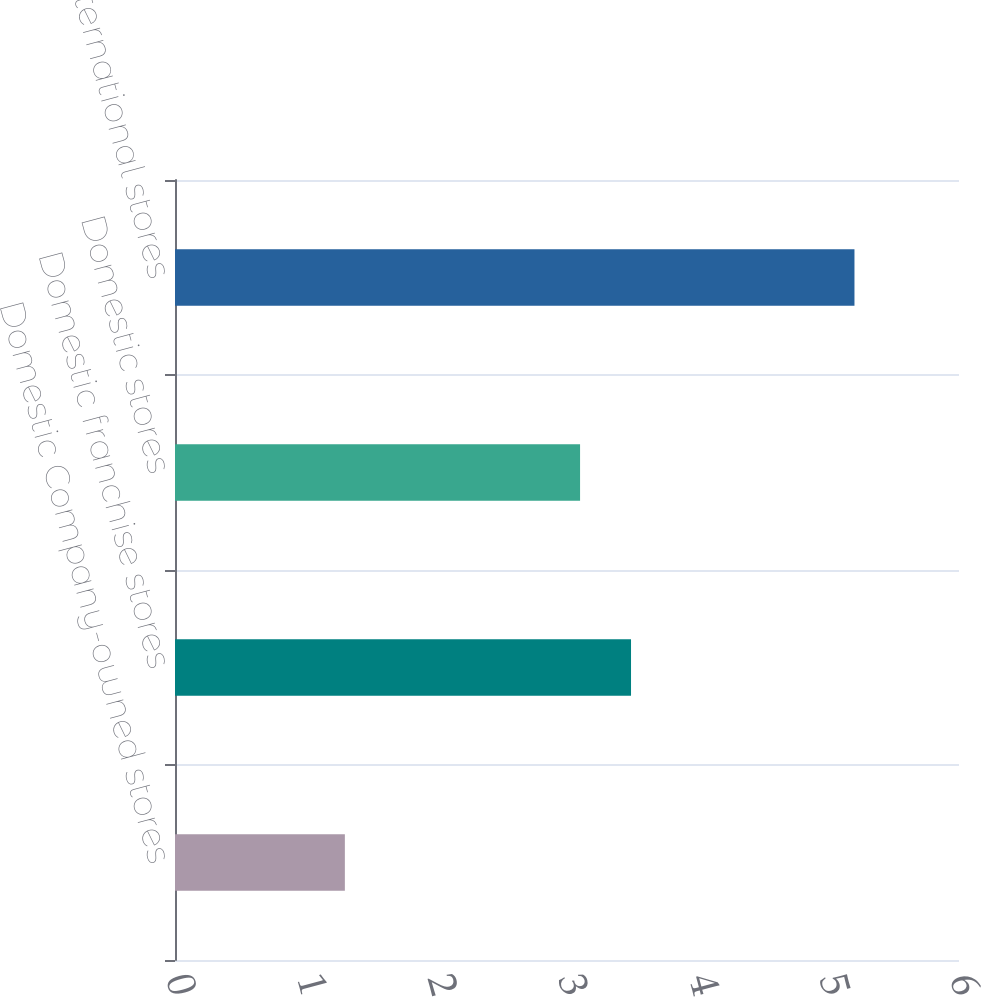<chart> <loc_0><loc_0><loc_500><loc_500><bar_chart><fcel>Domestic Company-owned stores<fcel>Domestic franchise stores<fcel>Domestic stores<fcel>International stores<nl><fcel>1.3<fcel>3.49<fcel>3.1<fcel>5.2<nl></chart> 